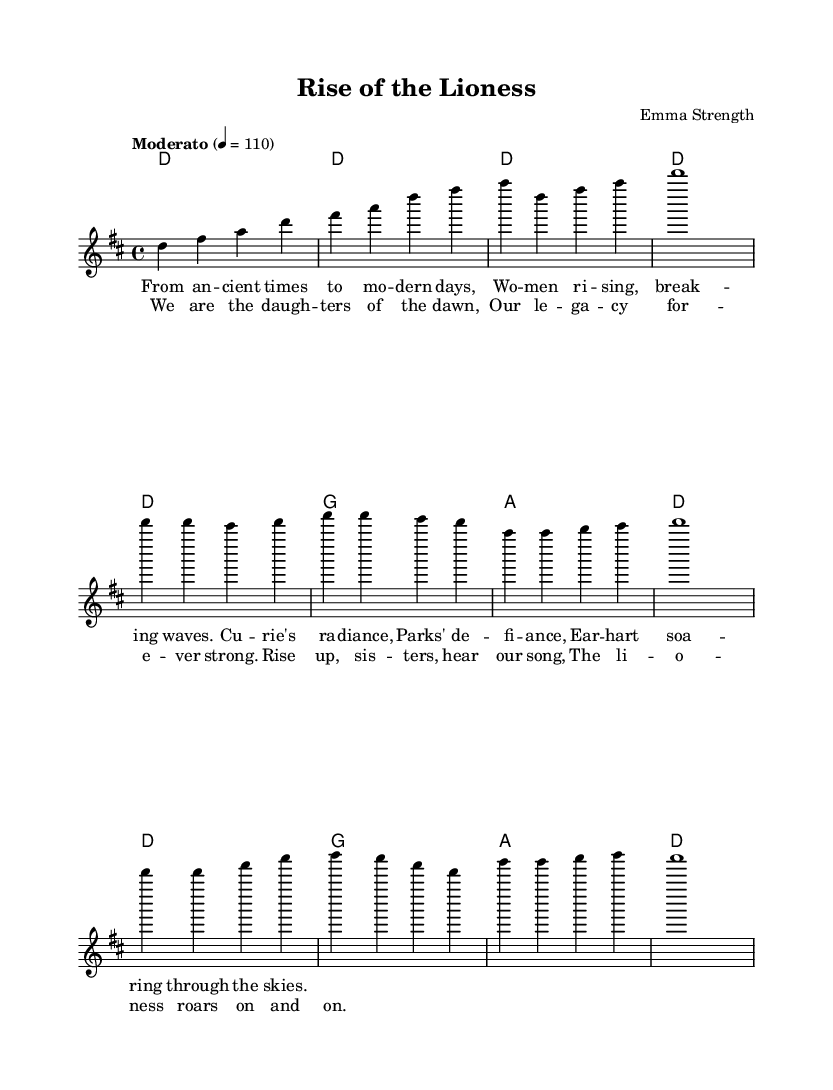What is the key signature of this music? The key signature is indicated in the global settings at the beginning of the score. It shows that the piece is set in D major, which has two sharps (F# and C#).
Answer: D major What is the time signature of this music? The time signature is also specified in the global section and indicates a 4/4 measure, meaning there are four beats in each measure and the quarter note receives one beat.
Answer: 4/4 What is the tempo marking of this music? The tempo is indicated in the global section with "Moderato" at a speed of 110 quarter notes per minute. This describes a moderate pace for the piece.
Answer: Moderato, 110 How many measures are in the chorus section? By examining the chorus lyrics, we see that the melody associated with it spans four measures: the first phrase contains two measures followed by another two measures.
Answer: Four What is the main theme celebrated in the lyrics? The lyrics discuss women's strength, achievements, and history, specifically referencing notable women such as Marie Curie, Rosa Parks, and Amelia Earhart, signifying empowerment and legacy.
Answer: Women's empowerment How does the song conclude musically? The song’s music transitions from the chorus to an extended final measure (a whole note), which suggests a strong and definitive ending that underscores the song's theme of resilience and empowerment.
Answer: A whole note Which female figure is mentioned for her radiance? The lyrics specifically reference Marie Curie, recognized for her significant contributions to science and being a pioneer for women in that field.
Answer: Marie Curie 